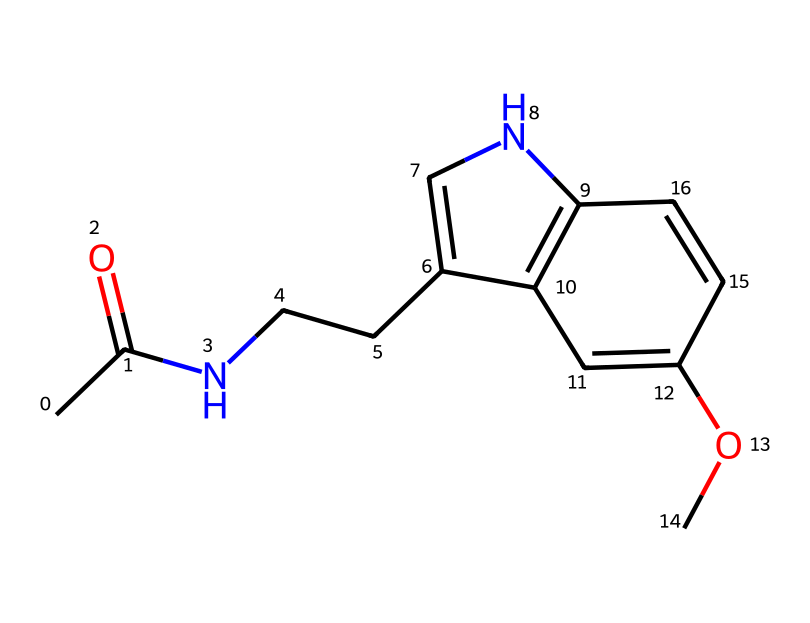What is the molecular formula of this compound? To determine the molecular formula, count the number of carbons (C), hydrogens (H), nitrogens (N), and oxygens (O) in the structure represented by the SMILES. The molecule contains 13 carbon atoms, 16 hydrogen atoms, 1 nitrogen atom, and 1 oxygen atom, leading to a molecular formula of C13H16N2O.
Answer: C13H16N2O How many rings are present in the structure? By analyzing the structure represented in the SMILES, identify the cyclic components. There are two distinct ring structures visible in the compound, indicating that it has two rings.
Answer: 2 What functional groups are present? Examine the structure for specific groups that define the functionality. The presence of an amine group (indicated by the nitrogen atom) and a methoxy group (the O connected to a carbon chain) suggests it has both an amine and an ether functional group.
Answer: amine and ether Does this compound contain any double bonds? Check the structure for any pi bonds connecting atoms, as indicated by the "=" symbols in the SMILES notation. The representation reveals several double bonds, confirming that this compound contains double bonds.
Answer: yes What role does this compound play in the human body? Reviewing the chemical's context suggests its associated biological activity. Known primarily as a hormone involved in regulating sleep-wake cycles, melatonin plays a crucial role in managing circadian rhythms and sleep patterns.
Answer: sleep-regulating hormone What type of medicinal classification does this compound belong to? Determine the classification based on the primary use of the compound. Melatonin is classified as a pharmaceutical agent specifically designed for sleep disorders and managing irregular schedules, categorizing it as a therapeutic compound.
Answer: therapeutic compound 